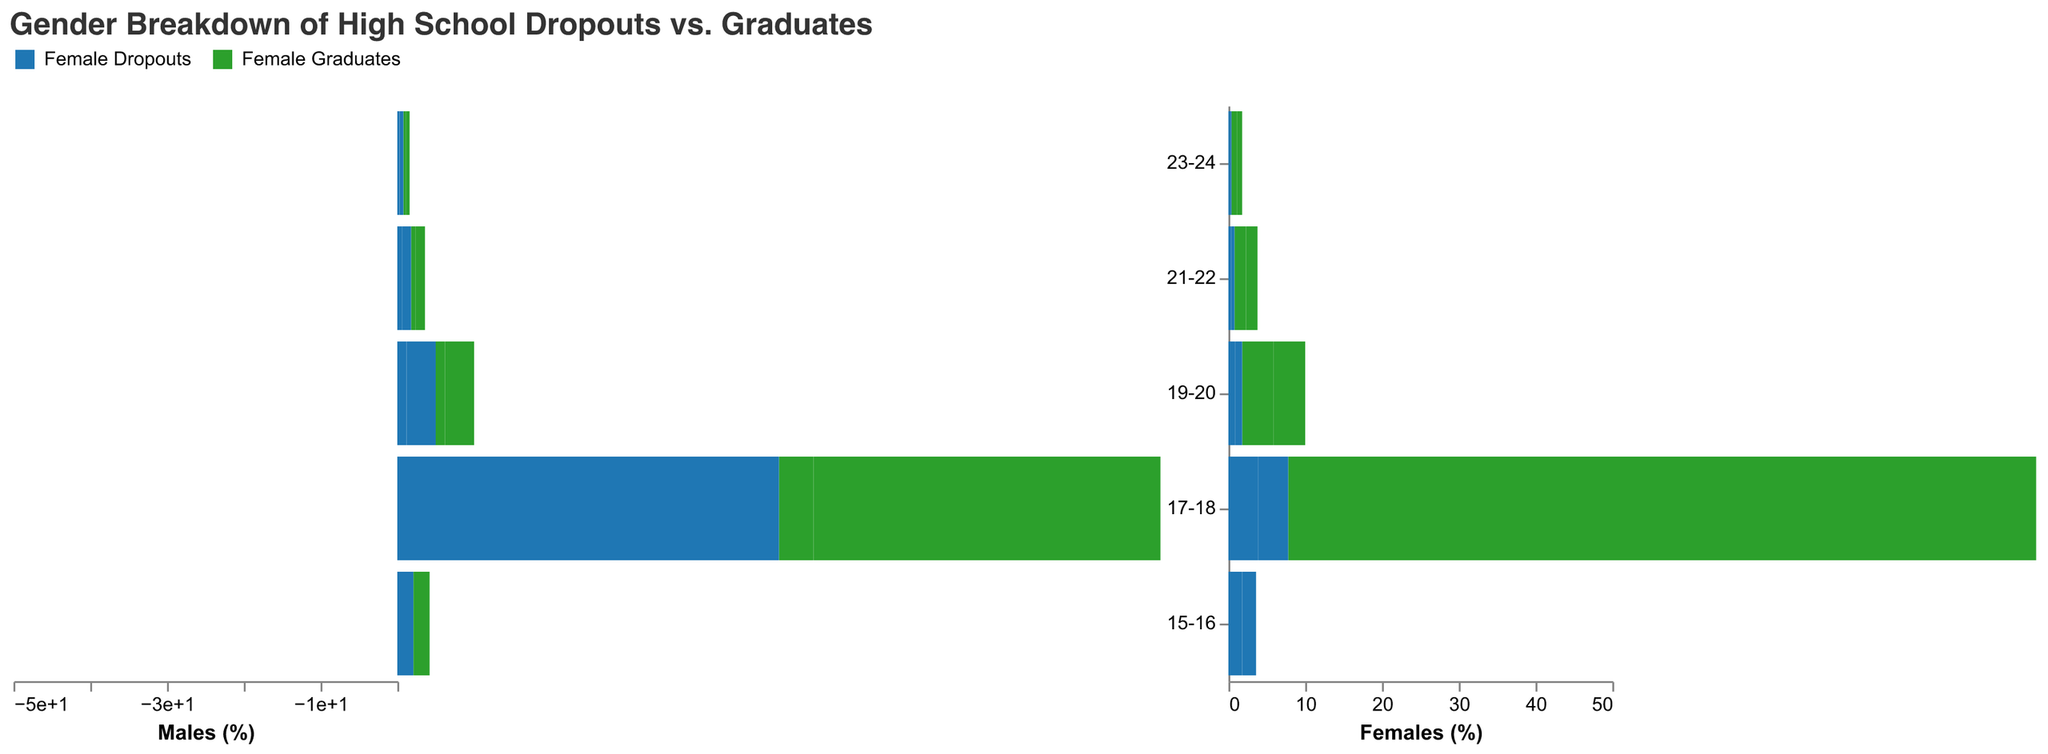What is the age group with the highest percentage of female dropouts? Looking at the figure, the "Female Dropouts" bar is highest for the age group 17-18.
Answer: 17-18 What is the total percentage of male graduates in the 17-18 age group? Referring to the figure, the bar under "Male Graduates" for the 17-18 age group shows a value of 45.2%.
Answer: 45.2% How do the percentages of male and female dropouts compare in the 19-20 age group? The heights of the "Male Dropouts" and "Female Dropouts" bars in the 19-20 age group are compared. Male dropouts are at 1.2%, and female dropouts are at 0.9%. Male dropouts are higher.
Answer: Male dropouts are higher What is the sum of male and female dropouts in the 15-16 age group? Adding the percentages of "Male Dropouts" and "Female Dropouts" in the 15-16 age group: 2.1% (male) + 1.8% (female) = 3.9% total dropouts.
Answer: 3.9% Which gender has a higher percentage of graduates in the 23-24 age group? Comparing "Male Graduates" and "Female Graduates" bars in the 23-24 age group: Male graduates are at 0.5%, and female graduates are at 0.7%. Female graduates are higher.
Answer: Female graduates What is the difference between male and female graduates in the 19-20 age group? Subtracting the percentage of "Female Graduates" from "Male Graduates" in the 19-20 age group: 3.8% (male) - 4.1% (female) = -0.3%.
Answer: -0.3% Which age group has the lowest percentage of female graduates? Observing the "Female Graduates" bars, the age group 23-24 has the lowest at 0.7%.
Answer: 23-24 How does the percentage of male graduates in the 21-22 age group compare to the percentage of male dropouts in the same age group? Viewing the bars for "Male Graduates" and "Male Dropouts" in the 21-22 age group: Male graduates are at 1.2%, and male dropouts are at 0.6%. Male graduates are higher.
Answer: Male graduates are higher 